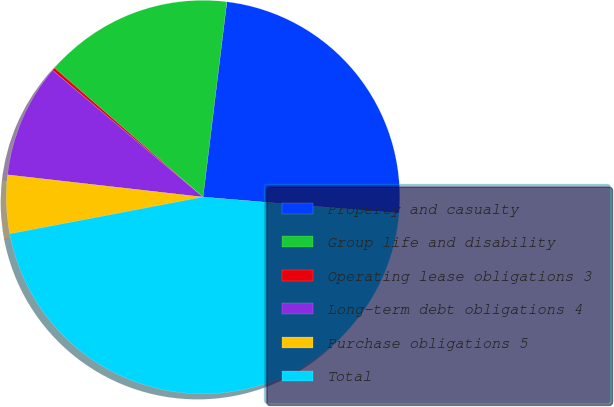Convert chart. <chart><loc_0><loc_0><loc_500><loc_500><pie_chart><fcel>Property and casualty<fcel>Group life and disability<fcel>Operating lease obligations 3<fcel>Long-term debt obligations 4<fcel>Purchase obligations 5<fcel>Total<nl><fcel>24.38%<fcel>15.54%<fcel>0.25%<fcel>9.34%<fcel>4.8%<fcel>45.69%<nl></chart> 